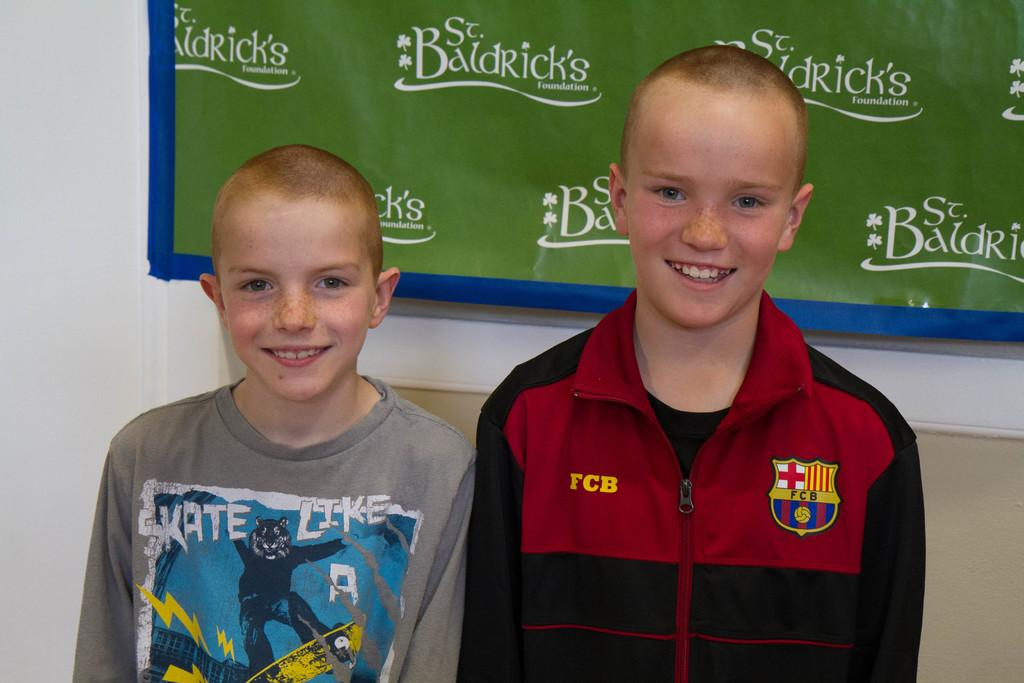Who is present in the image? There are boys in the image. What expression do the boys have? The boys are smiling. What can be seen in the background of the image? There is a banner in the background of the image. What is written on the banner? The banner has text on it. Can you see a scale being used by the boys in the image? There is no scale present in the image. Are the boys flying in the image? The boys are not flying in the image; they are standing on the ground. 